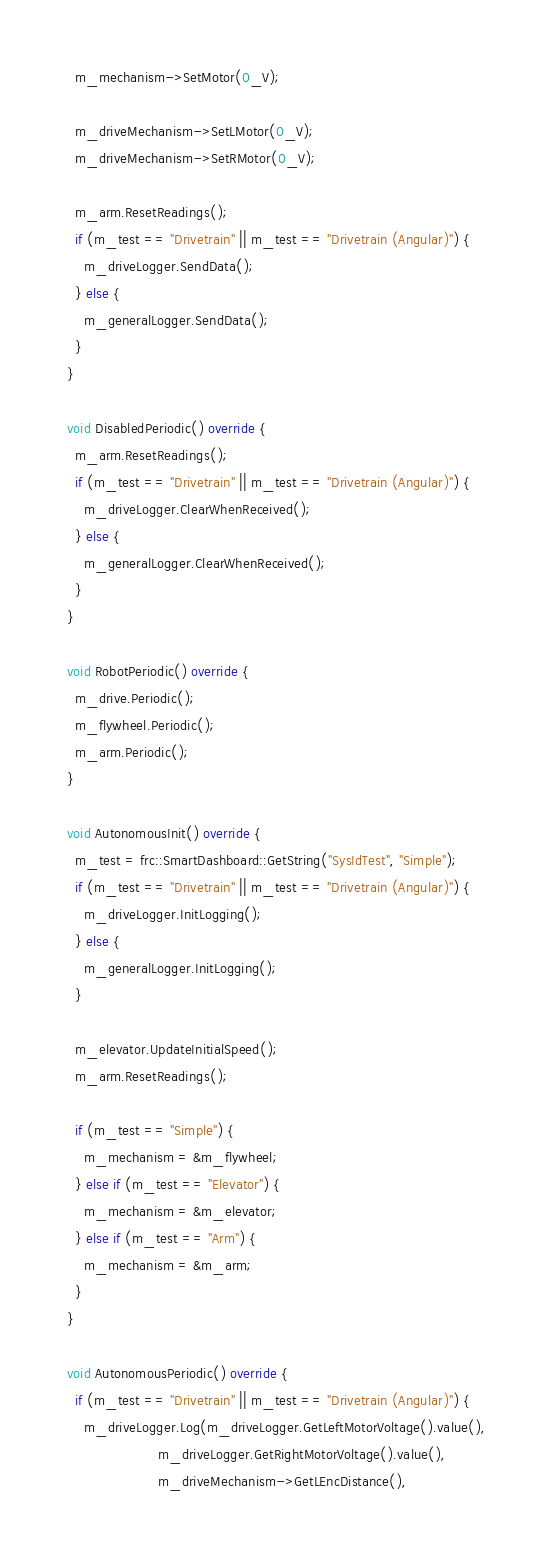<code> <loc_0><loc_0><loc_500><loc_500><_C++_>    m_mechanism->SetMotor(0_V);

    m_driveMechanism->SetLMotor(0_V);
    m_driveMechanism->SetRMotor(0_V);

    m_arm.ResetReadings();
    if (m_test == "Drivetrain" || m_test == "Drivetrain (Angular)") {
      m_driveLogger.SendData();
    } else {
      m_generalLogger.SendData();
    }
  }

  void DisabledPeriodic() override {
    m_arm.ResetReadings();
    if (m_test == "Drivetrain" || m_test == "Drivetrain (Angular)") {
      m_driveLogger.ClearWhenReceived();
    } else {
      m_generalLogger.ClearWhenReceived();
    }
  }

  void RobotPeriodic() override {
    m_drive.Periodic();
    m_flywheel.Periodic();
    m_arm.Periodic();
  }

  void AutonomousInit() override {
    m_test = frc::SmartDashboard::GetString("SysIdTest", "Simple");
    if (m_test == "Drivetrain" || m_test == "Drivetrain (Angular)") {
      m_driveLogger.InitLogging();
    } else {
      m_generalLogger.InitLogging();
    }

    m_elevator.UpdateInitialSpeed();
    m_arm.ResetReadings();

    if (m_test == "Simple") {
      m_mechanism = &m_flywheel;
    } else if (m_test == "Elevator") {
      m_mechanism = &m_elevator;
    } else if (m_test == "Arm") {
      m_mechanism = &m_arm;
    }
  }

  void AutonomousPeriodic() override {
    if (m_test == "Drivetrain" || m_test == "Drivetrain (Angular)") {
      m_driveLogger.Log(m_driveLogger.GetLeftMotorVoltage().value(),
                        m_driveLogger.GetRightMotorVoltage().value(),
                        m_driveMechanism->GetLEncDistance(),</code> 